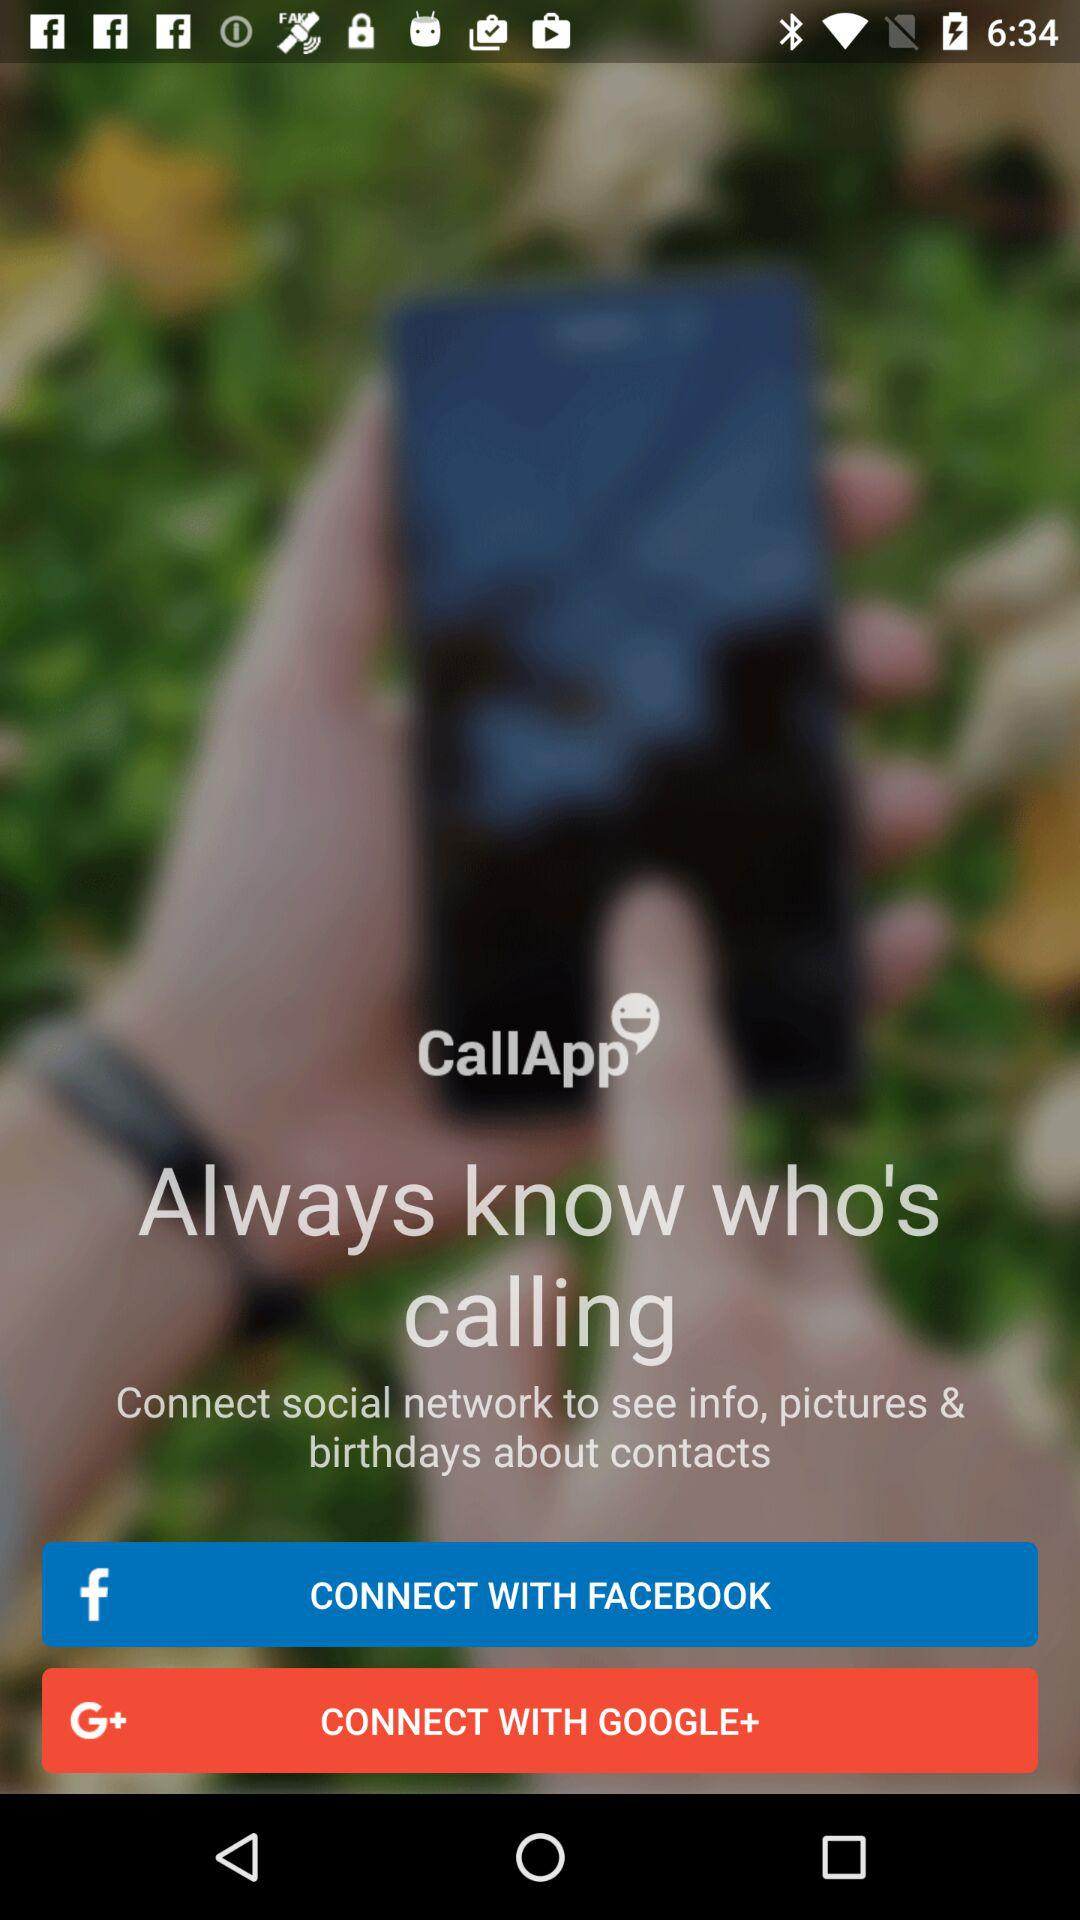What is the name of the application? The name of the application is "CallApp". 